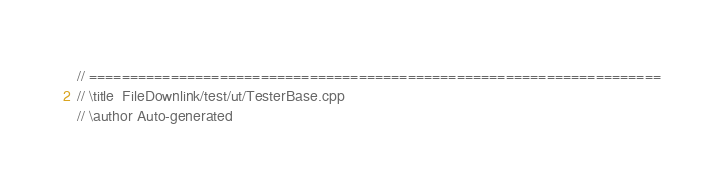<code> <loc_0><loc_0><loc_500><loc_500><_C++_>// ======================================================================
// \title  FileDownlink/test/ut/TesterBase.cpp
// \author Auto-generated</code> 